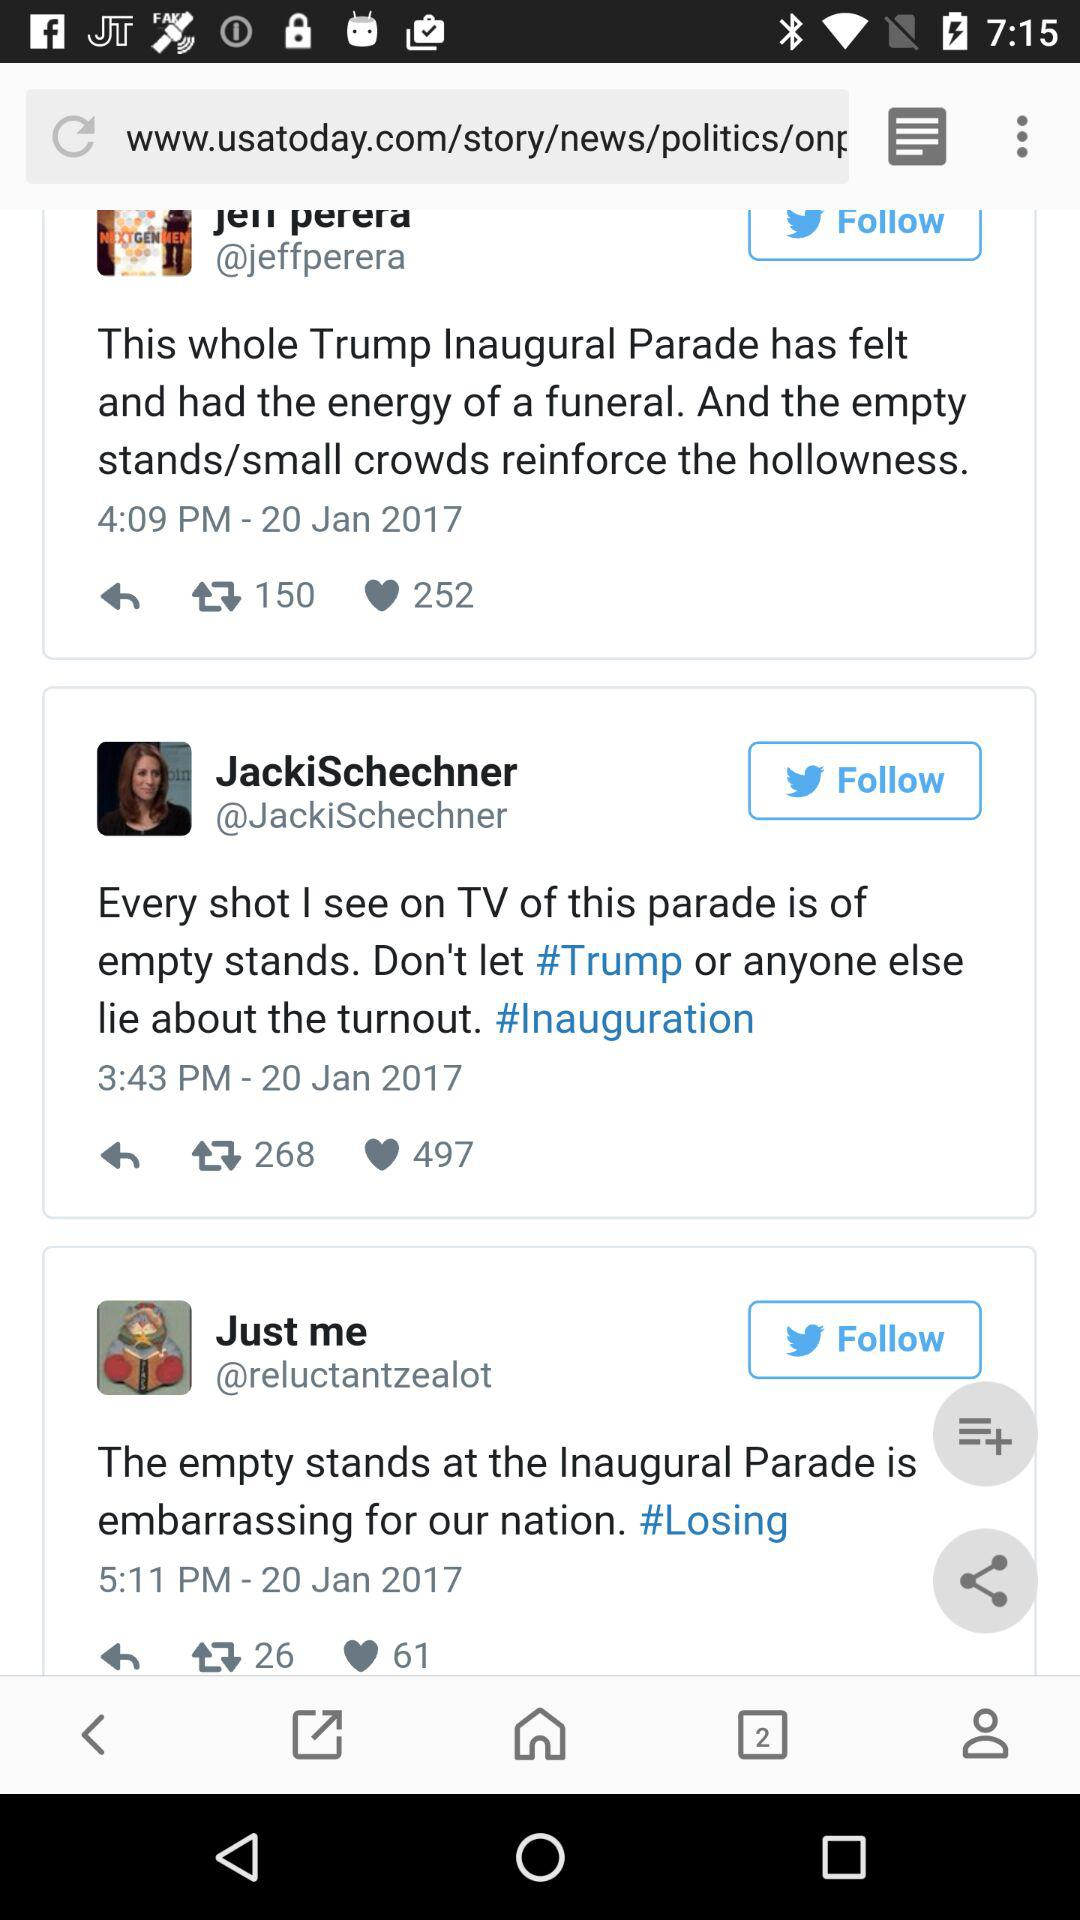What time did JackiSchechner post? JackiSchechner posted at 3:43 p.m. 